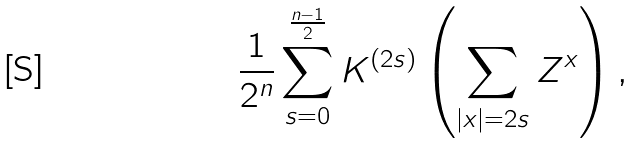Convert formula to latex. <formula><loc_0><loc_0><loc_500><loc_500>\frac { 1 } { 2 ^ { n } } \sum _ { s = 0 } ^ { \frac { n - 1 } { 2 } } K ^ { ( 2 s ) } \left ( \sum _ { | x | = 2 s } Z ^ { x } \right ) ,</formula> 